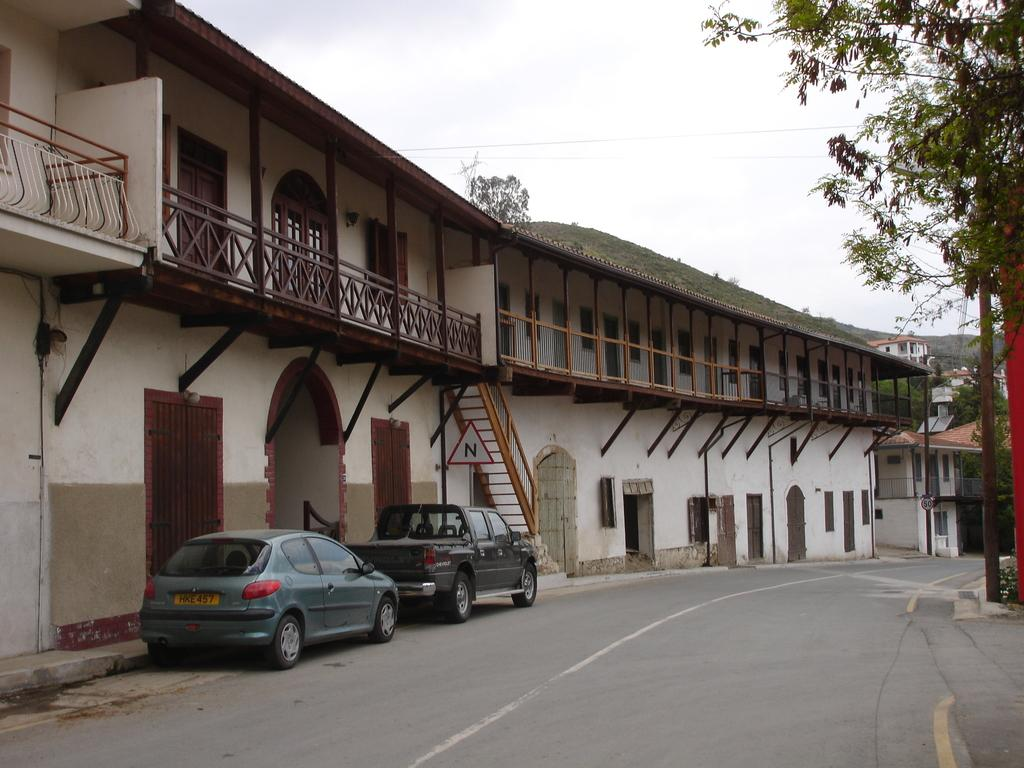What is the main feature in the center of the image? There is a road in the center of the image. What types of vehicles can be seen on the road? There are cars in the image. What structures are visible in the image? There are buildings in the image. What is visible at the top of the image? The sky is visible at the top of the image. What type of natural landform can be seen in the background? There are mountains in the image. What type of straw is being used to plough the field in the image? There is no field or plough visible in the image; it features a road, cars, buildings, the sky, and mountains. 